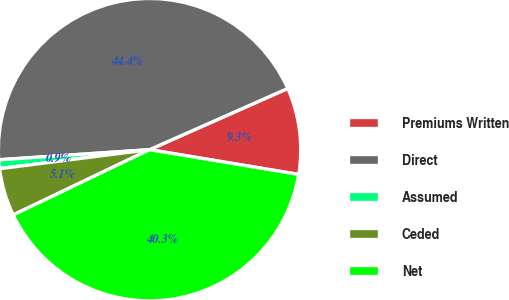Convert chart. <chart><loc_0><loc_0><loc_500><loc_500><pie_chart><fcel>Premiums Written<fcel>Direct<fcel>Assumed<fcel>Ceded<fcel>Net<nl><fcel>9.26%<fcel>44.43%<fcel>0.94%<fcel>5.1%<fcel>40.27%<nl></chart> 